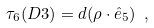<formula> <loc_0><loc_0><loc_500><loc_500>\tau _ { 6 } ( D 3 ) = d ( \rho \cdot \hat { e } _ { 5 } ) \ ,</formula> 